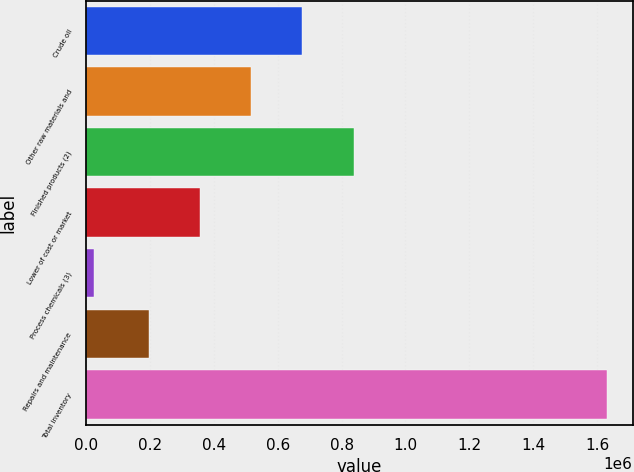<chart> <loc_0><loc_0><loc_500><loc_500><bar_chart><fcel>Crude oil<fcel>Other raw materials and<fcel>Finished products (2)<fcel>Lower of cost or market<fcel>Process chemicals (3)<fcel>Repairs and maintenance<fcel>Total inventory<nl><fcel>677352<fcel>516822<fcel>837882<fcel>356292<fcel>24792<fcel>195762<fcel>1.63009e+06<nl></chart> 